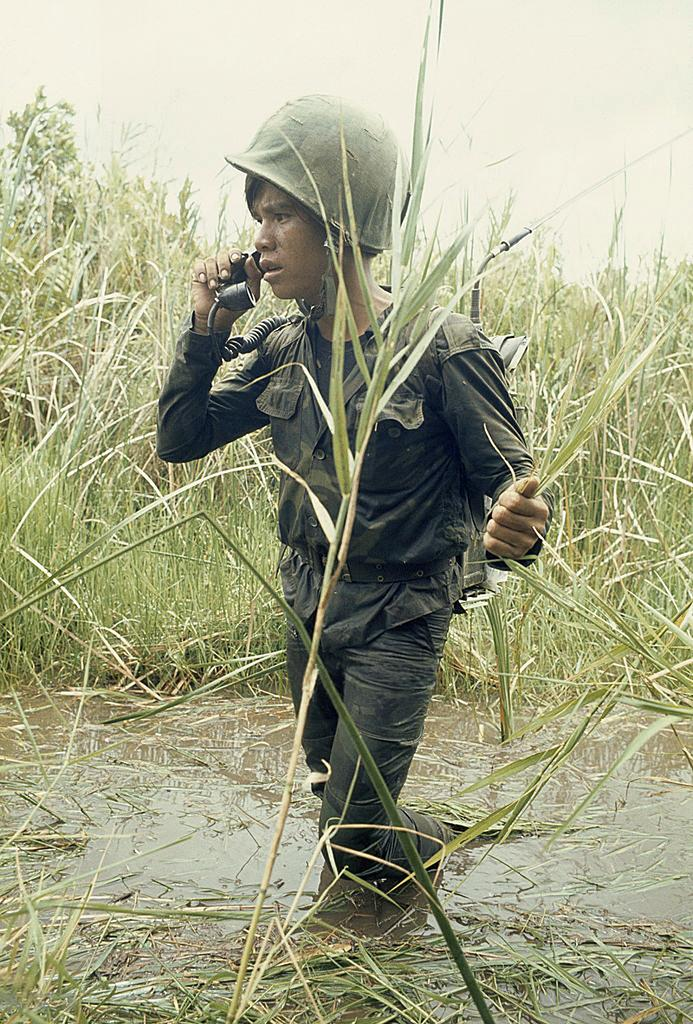What is the main subject in the foreground of the picture? There is a man in the foreground of the picture. What is the man doing in the image? The man is walking in the water and holding grass. What is the man holding in his hands? The man is holding a walkie-talkie in both hands. What can be seen in the background of the image? Water, grass, and the sky are visible in the background of the image. What type of instrument is the man playing in the image? There is no instrument present in the image; the man is holding a walkie-talkie and grass. How many ducks can be seen swimming in the water in the image? There are no ducks visible in the image; only the man and the water are present. 